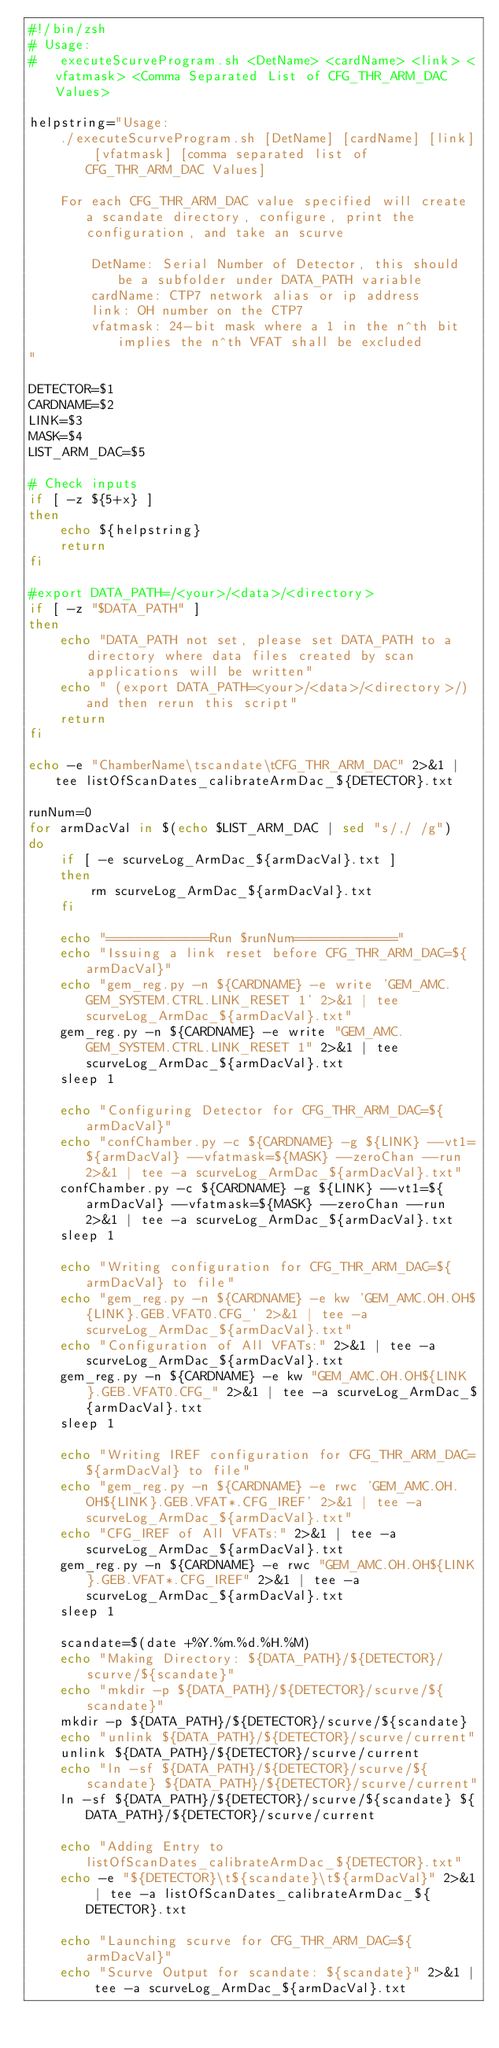<code> <loc_0><loc_0><loc_500><loc_500><_Bash_>#!/bin/zsh
# Usage:
#   executeScurveProgram.sh <DetName> <cardName> <link> <vfatmask> <Comma Separated List of CFG_THR_ARM_DAC Values>

helpstring="Usage:
    ./executeScurveProgram.sh [DetName] [cardName] [link] [vfatmask] [comma separated list of CFG_THR_ARM_DAC Values]
        
    For each CFG_THR_ARM_DAC value specified will create a scandate directory, configure, print the configuration, and take an scurve

        DetName: Serial Number of Detector, this should be a subfolder under DATA_PATH variable
        cardName: CTP7 network alias or ip address
        link: OH number on the CTP7
        vfatmask: 24-bit mask where a 1 in the n^th bit implies the n^th VFAT shall be excluded
"

DETECTOR=$1
CARDNAME=$2
LINK=$3
MASK=$4
LIST_ARM_DAC=$5

# Check inputs
if [ -z ${5+x} ] 
then
    echo ${helpstring}
    return
fi

#export DATA_PATH=/<your>/<data>/<directory>
if [ -z "$DATA_PATH" ]
then
    echo "DATA_PATH not set, please set DATA_PATH to a directory where data files created by scan applications will be written"
    echo " (export DATA_PATH=<your>/<data>/<directory>/) and then rerun this script"
    return
fi

echo -e "ChamberName\tscandate\tCFG_THR_ARM_DAC" 2>&1 | tee listOfScanDates_calibrateArmDac_${DETECTOR}.txt

runNum=0
for armDacVal in $(echo $LIST_ARM_DAC | sed "s/,/ /g")
do
    if [ -e scurveLog_ArmDac_${armDacVal}.txt ]
    then
        rm scurveLog_ArmDac_${armDacVal}.txt
    fi

    echo "=============Run $runNum============="
    echo "Issuing a link reset before CFG_THR_ARM_DAC=${armDacVal}"
    echo "gem_reg.py -n ${CARDNAME} -e write 'GEM_AMC.GEM_SYSTEM.CTRL.LINK_RESET 1' 2>&1 | tee scurveLog_ArmDac_${armDacVal}.txt"
    gem_reg.py -n ${CARDNAME} -e write "GEM_AMC.GEM_SYSTEM.CTRL.LINK_RESET 1" 2>&1 | tee scurveLog_ArmDac_${armDacVal}.txt
    sleep 1

    echo "Configuring Detector for CFG_THR_ARM_DAC=${armDacVal}"
    echo "confChamber.py -c ${CARDNAME} -g ${LINK} --vt1=${armDacVal} --vfatmask=${MASK} --zeroChan --run 2>&1 | tee -a scurveLog_ArmDac_${armDacVal}.txt"
    confChamber.py -c ${CARDNAME} -g ${LINK} --vt1=${armDacVal} --vfatmask=${MASK} --zeroChan --run 2>&1 | tee -a scurveLog_ArmDac_${armDacVal}.txt
    sleep 1
    
    echo "Writing configuration for CFG_THR_ARM_DAC=${armDacVal} to file"
    echo "gem_reg.py -n ${CARDNAME} -e kw 'GEM_AMC.OH.OH${LINK}.GEB.VFAT0.CFG_' 2>&1 | tee -a scurveLog_ArmDac_${armDacVal}.txt"
    echo "Configuration of All VFATs:" 2>&1 | tee -a scurveLog_ArmDac_${armDacVal}.txt
    gem_reg.py -n ${CARDNAME} -e kw "GEM_AMC.OH.OH${LINK}.GEB.VFAT0.CFG_" 2>&1 | tee -a scurveLog_ArmDac_${armDacVal}.txt
    sleep 1

    echo "Writing IREF configuration for CFG_THR_ARM_DAC=${armDacVal} to file"
    echo "gem_reg.py -n ${CARDNAME} -e rwc 'GEM_AMC.OH.OH${LINK}.GEB.VFAT*.CFG_IREF' 2>&1 | tee -a scurveLog_ArmDac_${armDacVal}.txt"
    echo "CFG_IREF of All VFATs:" 2>&1 | tee -a scurveLog_ArmDac_${armDacVal}.txt
    gem_reg.py -n ${CARDNAME} -e rwc "GEM_AMC.OH.OH${LINK}.GEB.VFAT*.CFG_IREF" 2>&1 | tee -a scurveLog_ArmDac_${armDacVal}.txt
    sleep 1

    scandate=$(date +%Y.%m.%d.%H.%M)
    echo "Making Directory: ${DATA_PATH}/${DETECTOR}/scurve/${scandate}"
    echo "mkdir -p ${DATA_PATH}/${DETECTOR}/scurve/${scandate}"
    mkdir -p ${DATA_PATH}/${DETECTOR}/scurve/${scandate}
    echo "unlink ${DATA_PATH}/${DETECTOR}/scurve/current"
    unlink ${DATA_PATH}/${DETECTOR}/scurve/current
    echo "ln -sf ${DATA_PATH}/${DETECTOR}/scurve/${scandate} ${DATA_PATH}/${DETECTOR}/scurve/current"
    ln -sf ${DATA_PATH}/${DETECTOR}/scurve/${scandate} ${DATA_PATH}/${DETECTOR}/scurve/current

    echo "Adding Entry to listOfScanDates_calibrateArmDac_${DETECTOR}.txt"
    echo -e "${DETECTOR}\t${scandate}\t${armDacVal}" 2>&1 | tee -a listOfScanDates_calibrateArmDac_${DETECTOR}.txt

    echo "Launching scurve for CFG_THR_ARM_DAC=${armDacVal}"
    echo "Scurve Output for scandate: ${scandate}" 2>&1 | tee -a scurveLog_ArmDac_${armDacVal}.txt</code> 